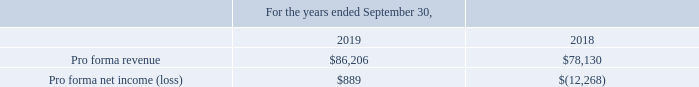The following unaudited pro forma financial information is presented as if the acquisitions had taken place at the beginning of the periods presented and should not be taken as representative of the Company’s future consolidated results of operations. The following unaudited pro forma information includes adjustments for the amortization expense related to the identified intangible assets.
The following table summarizes the Company’s unaudited pro forma financial information is presented as if the acquisitions occurred on October 1, 2017 (amounts shown in thousands):
For the year ended September 30, 2018, revenue of $9.1 million and a net loss of $5.3 million related to the A2iA and ICAR businesses since the respective acquisition dates are included in the Company's consolidated statements of operations.
What does the table provide for us? The company’s unaudited pro forma financial information is presented as if the acquisitions occurred on october 1, 2017. What are the revenue and net loss related to the A2iA and ICAR businesses for the year ended September 30, 2018, respectively? $9.1 million, $5.3 million. What are the pro forma revenues in 2018 and 2019, respectively?
Answer scale should be: thousand. $86,206, $78,130. What is the percentage change in pro forma revenue from 2018 to 2019? 
Answer scale should be: percent. (86,206-78,130)/78,130 
Answer: 10.34. What is the average pro forma net income (loss) for the last 2 years, i.e. 2018 and 2019?
Answer scale should be: thousand. (889+(-12,268))/2 
Answer: -5689.5. Which year has a higher amount of pro forma revenue? 86,206> 78,130
Answer: 2019. 